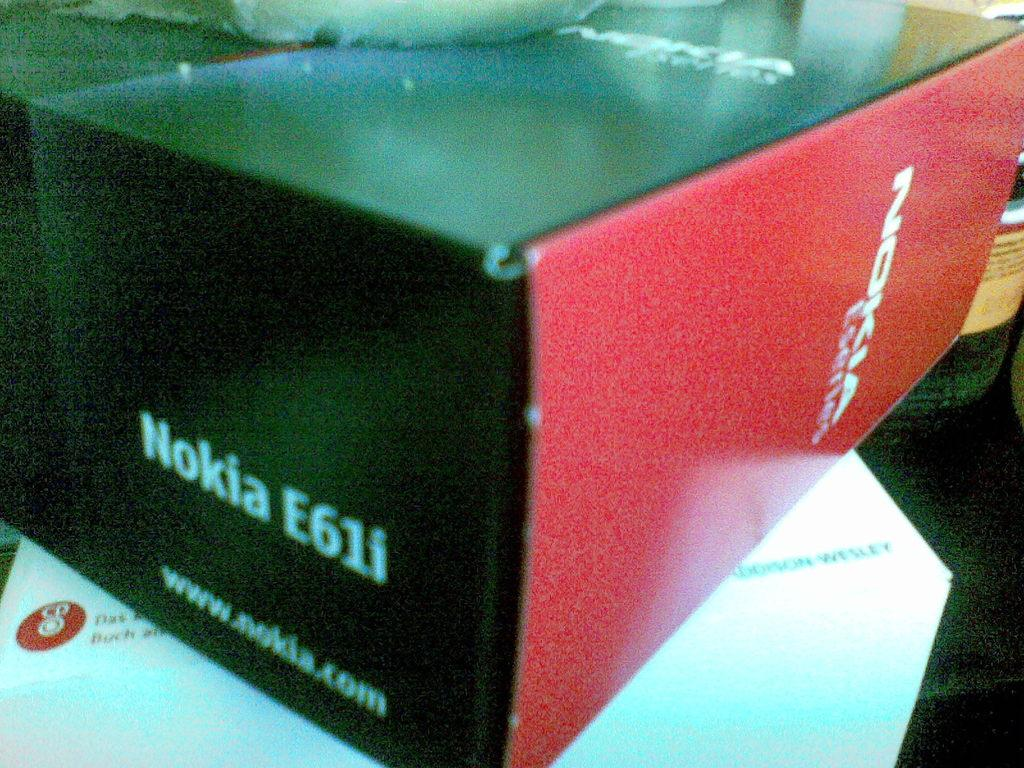<image>
Offer a succinct explanation of the picture presented. A grainy close up shot of a Nokia E61i box. 